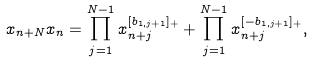<formula> <loc_0><loc_0><loc_500><loc_500>x _ { n + N } x _ { n } = \prod _ { j = 1 } ^ { N - 1 } x _ { n + j } ^ { [ b _ { 1 , j + 1 } ] _ { + } } + \prod _ { j = 1 } ^ { N - 1 } x _ { n + j } ^ { [ - b _ { 1 , j + 1 } ] _ { + } } ,</formula> 